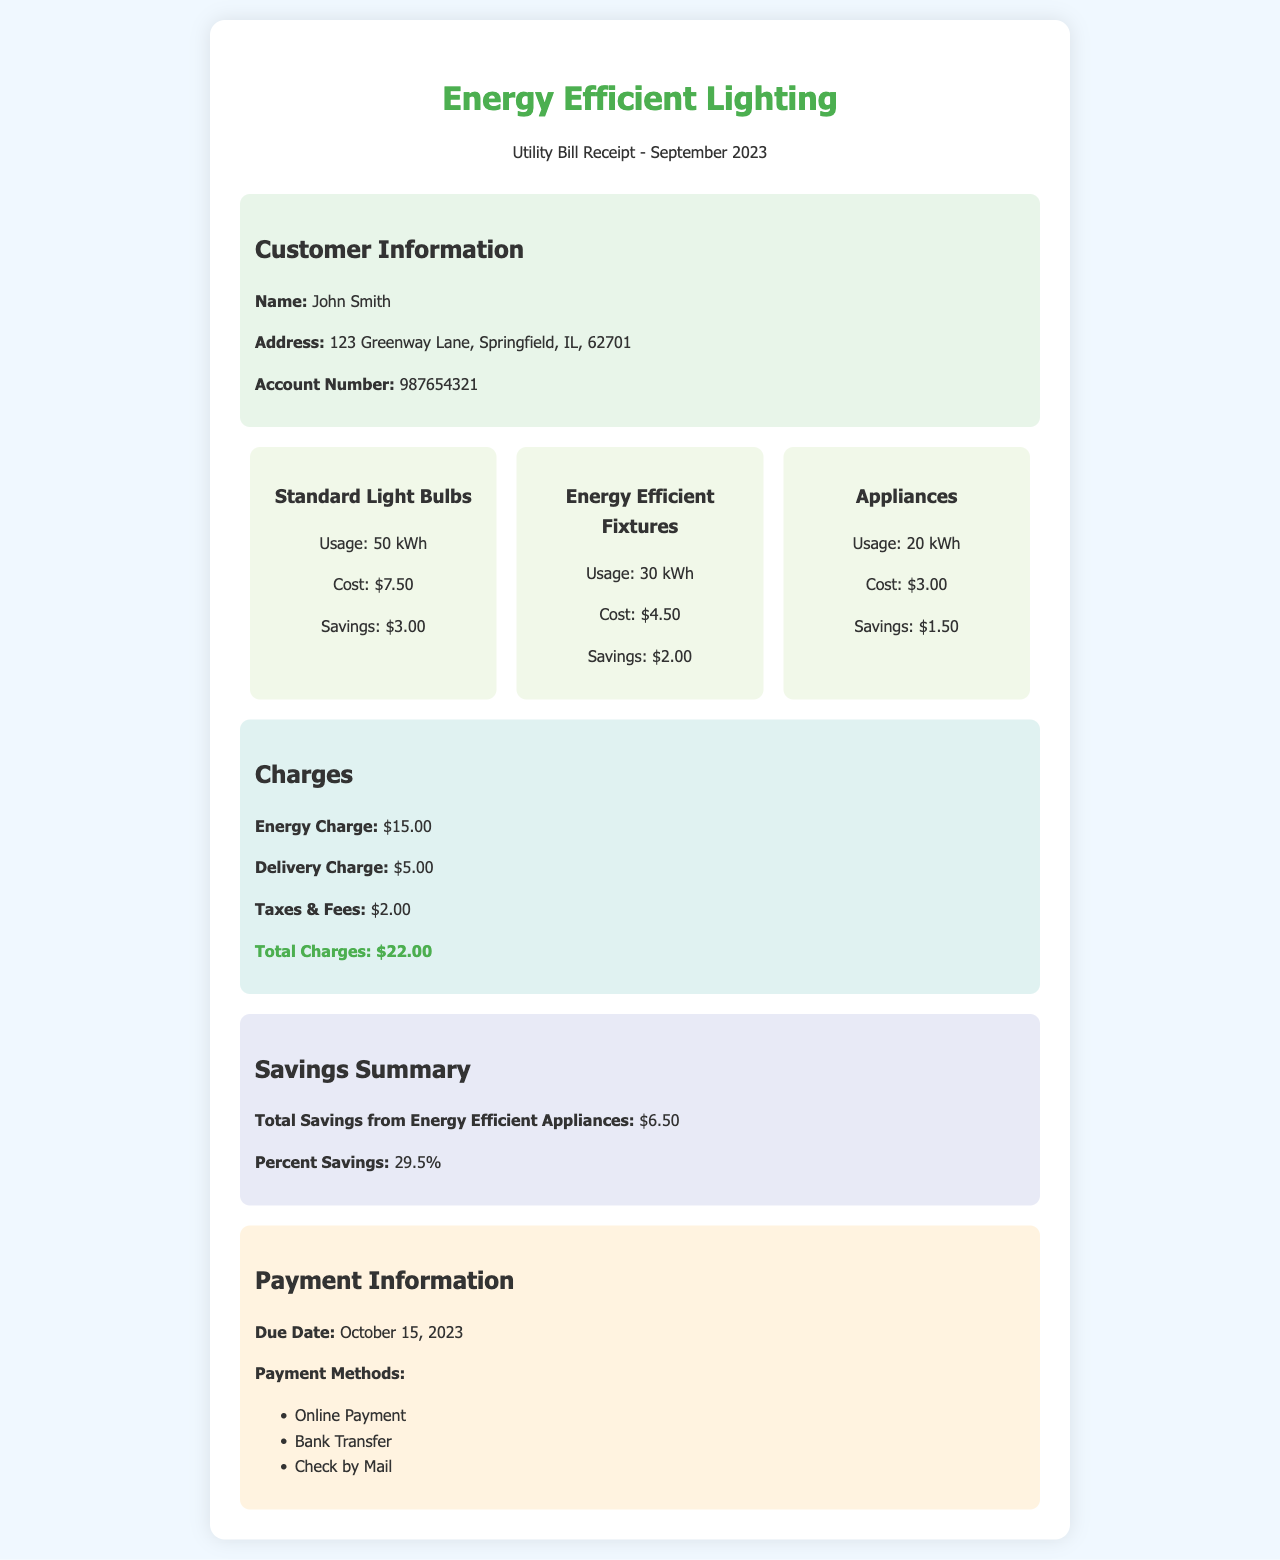What is the customer name? The customer's name is provided in the customer information section of the document.
Answer: John Smith What is the total charges amount? The total charges are listed under the charges section, which is calculated from various charges.
Answer: $22.00 How much energy was used by energy-efficient fixtures? The usage of energy-efficient fixtures is specified in the usage breakdown of the document.
Answer: 30 kWh What is the total savings from energy-efficient appliances? The total savings is highlighted in the savings summary section of the document.
Answer: $6.50 What is the due date for payment? The due date for payment is mentioned in the payment information section of the document.
Answer: October 15, 2023 How much was spent on standard light bulbs? The cost of standard light bulbs is stated in the usage breakdown section of the document.
Answer: $7.50 What percentage savings is achieved? The percent savings from energy-efficient appliances is provided in the savings summary section.
Answer: 29.5% What is the address of the customer? The customer's address is included in the customer information section.
Answer: 123 Greenway Lane, Springfield, IL, 62701 What are the payment methods? The payment methods are listed in the payment information section of the document.
Answer: Online Payment, Bank Transfer, Check by Mail 